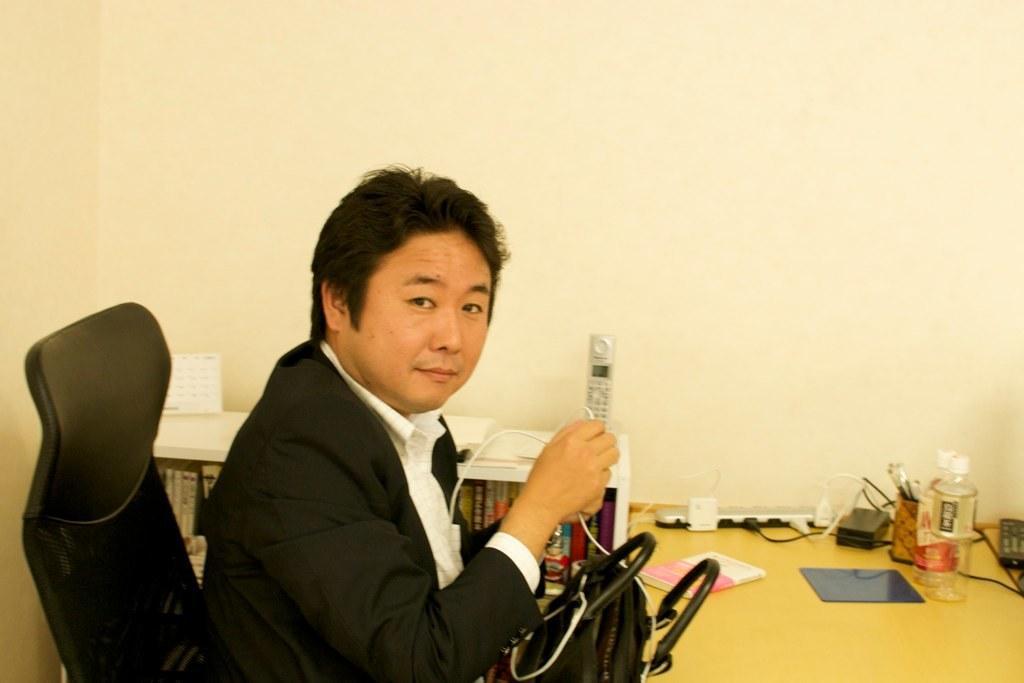Describe this image in one or two sentences. In this picture we can see a man who is sitting on the chair. He is in black color suit and this is bag. There is a table. On the table there is a bottle, and a book. On the background there is a wall. 